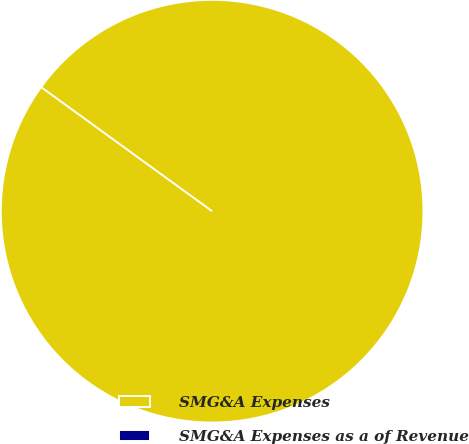<chart> <loc_0><loc_0><loc_500><loc_500><pie_chart><fcel>SMG&A Expenses<fcel>SMG&A Expenses as a of Revenue<nl><fcel>100.0%<fcel>0.0%<nl></chart> 